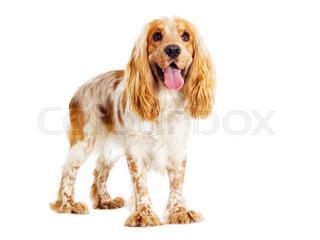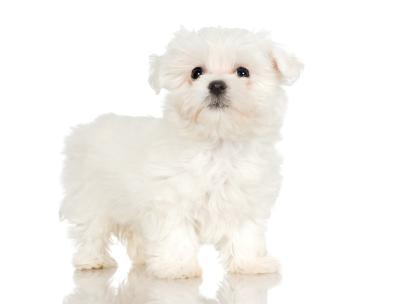The first image is the image on the left, the second image is the image on the right. For the images shown, is this caption "The dog in the image on the left is standing on all fours." true? Answer yes or no. Yes. 